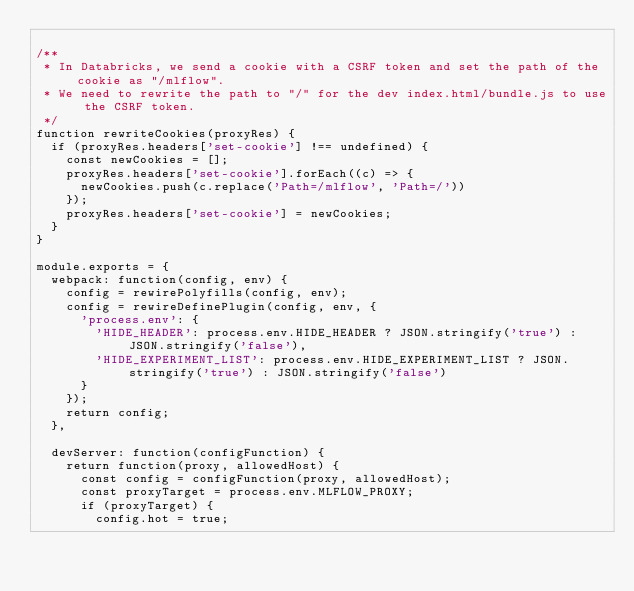Convert code to text. <code><loc_0><loc_0><loc_500><loc_500><_JavaScript_>
/**
 * In Databricks, we send a cookie with a CSRF token and set the path of the cookie as "/mlflow".
 * We need to rewrite the path to "/" for the dev index.html/bundle.js to use the CSRF token.
 */
function rewriteCookies(proxyRes) {
  if (proxyRes.headers['set-cookie'] !== undefined) {
    const newCookies = [];
    proxyRes.headers['set-cookie'].forEach((c) => {
      newCookies.push(c.replace('Path=/mlflow', 'Path=/'))
    });
    proxyRes.headers['set-cookie'] = newCookies;
  }
}

module.exports = {
  webpack: function(config, env) {
    config = rewirePolyfills(config, env);
    config = rewireDefinePlugin(config, env, {
      'process.env': {
        'HIDE_HEADER': process.env.HIDE_HEADER ? JSON.stringify('true') : JSON.stringify('false'),
        'HIDE_EXPERIMENT_LIST': process.env.HIDE_EXPERIMENT_LIST ? JSON.stringify('true') : JSON.stringify('false')
      }
    });
    return config;
  },

  devServer: function(configFunction) {
    return function(proxy, allowedHost) {
      const config = configFunction(proxy, allowedHost);
      const proxyTarget = process.env.MLFLOW_PROXY;
      if (proxyTarget) {
        config.hot = true;</code> 